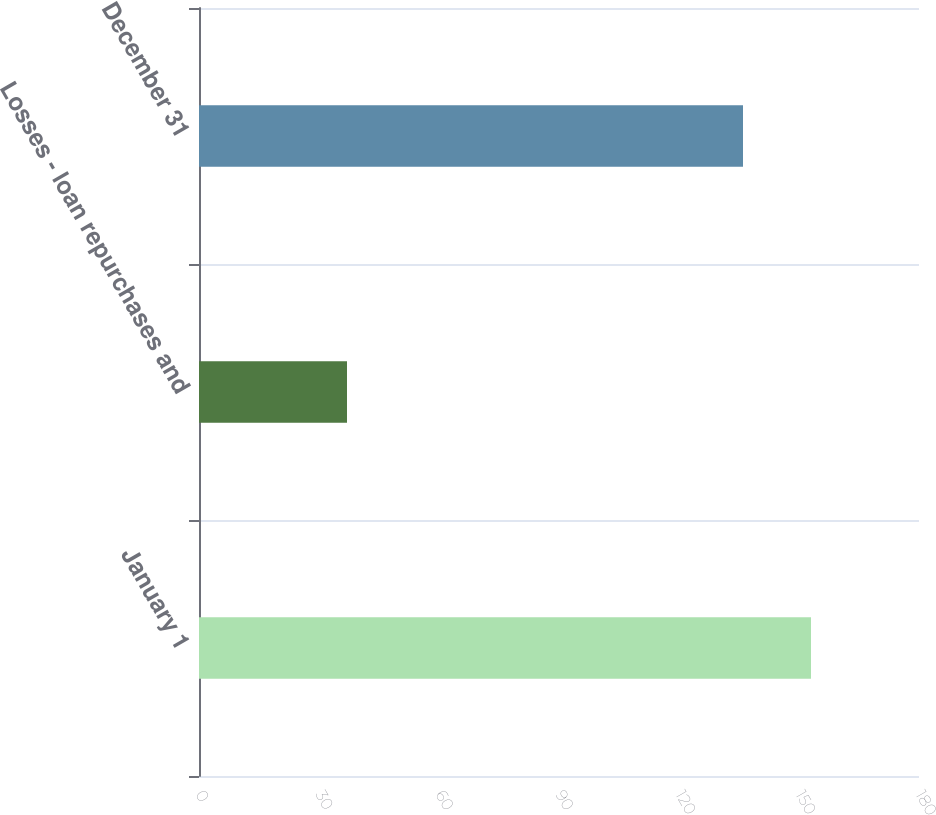Convert chart. <chart><loc_0><loc_0><loc_500><loc_500><bar_chart><fcel>January 1<fcel>Losses - loan repurchases and<fcel>December 31<nl><fcel>153<fcel>37<fcel>136<nl></chart> 